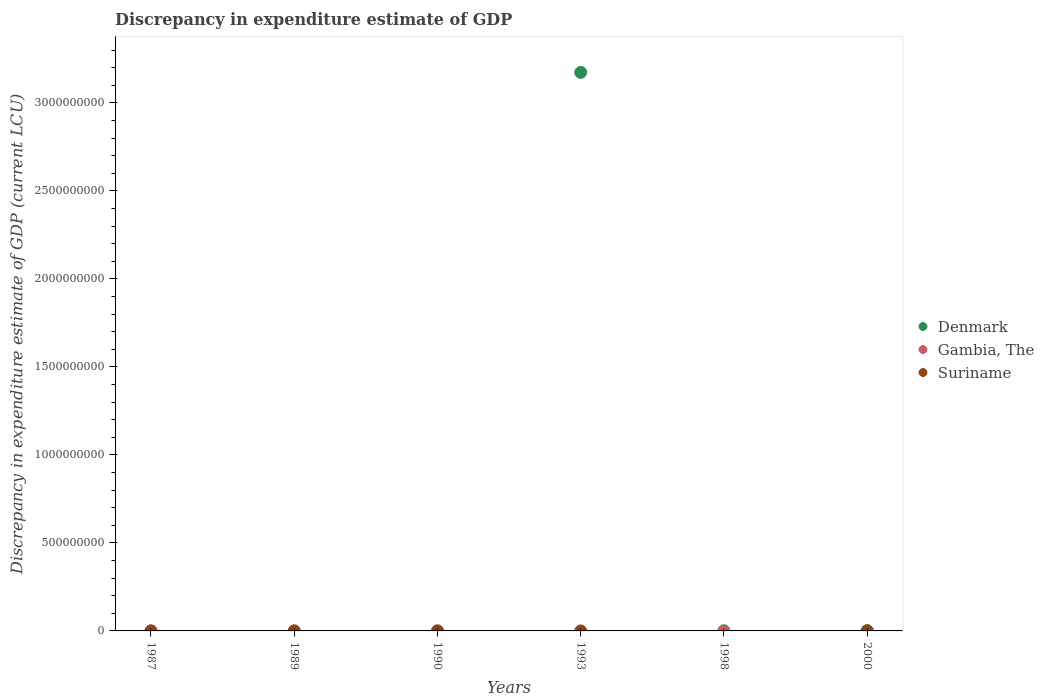Across all years, what is the maximum discrepancy in expenditure estimate of GDP in Denmark?
Your answer should be compact. 3.17e+09. In which year was the discrepancy in expenditure estimate of GDP in Suriname maximum?
Give a very brief answer. 2000. What is the total discrepancy in expenditure estimate of GDP in Denmark in the graph?
Make the answer very short. 3.18e+09. What is the difference between the discrepancy in expenditure estimate of GDP in Suriname in 1993 and the discrepancy in expenditure estimate of GDP in Gambia, The in 2000?
Your answer should be very brief. 0. What is the average discrepancy in expenditure estimate of GDP in Suriname per year?
Keep it short and to the point. 1.25e+05. In the year 2000, what is the difference between the discrepancy in expenditure estimate of GDP in Denmark and discrepancy in expenditure estimate of GDP in Suriname?
Offer a very short reply. 2.52e+05. Is the discrepancy in expenditure estimate of GDP in Suriname in 1989 less than that in 2000?
Your answer should be compact. Yes. What is the difference between the highest and the second highest discrepancy in expenditure estimate of GDP in Denmark?
Keep it short and to the point. 3.17e+09. What is the difference between the highest and the lowest discrepancy in expenditure estimate of GDP in Suriname?
Offer a terse response. 7.48e+05. Is it the case that in every year, the sum of the discrepancy in expenditure estimate of GDP in Gambia, The and discrepancy in expenditure estimate of GDP in Suriname  is greater than the discrepancy in expenditure estimate of GDP in Denmark?
Offer a terse response. No. How many dotlines are there?
Provide a succinct answer. 3. How many years are there in the graph?
Offer a terse response. 6. Does the graph contain grids?
Give a very brief answer. No. What is the title of the graph?
Your response must be concise. Discrepancy in expenditure estimate of GDP. What is the label or title of the Y-axis?
Ensure brevity in your answer.  Discrepancy in expenditure estimate of GDP (current LCU). What is the Discrepancy in expenditure estimate of GDP (current LCU) of Gambia, The in 1987?
Provide a short and direct response. 100. What is the Discrepancy in expenditure estimate of GDP (current LCU) in Denmark in 1989?
Provide a short and direct response. 0. What is the Discrepancy in expenditure estimate of GDP (current LCU) in Gambia, The in 1989?
Offer a terse response. 0. What is the Discrepancy in expenditure estimate of GDP (current LCU) of Suriname in 1989?
Make the answer very short. 100. What is the Discrepancy in expenditure estimate of GDP (current LCU) of Suriname in 1990?
Your answer should be very brief. 0. What is the Discrepancy in expenditure estimate of GDP (current LCU) of Denmark in 1993?
Offer a very short reply. 3.17e+09. What is the Discrepancy in expenditure estimate of GDP (current LCU) of Suriname in 1993?
Your answer should be very brief. 0. What is the Discrepancy in expenditure estimate of GDP (current LCU) of Denmark in 2000?
Keep it short and to the point. 1.00e+06. What is the Discrepancy in expenditure estimate of GDP (current LCU) of Gambia, The in 2000?
Give a very brief answer. 0. What is the Discrepancy in expenditure estimate of GDP (current LCU) in Suriname in 2000?
Provide a succinct answer. 7.48e+05. Across all years, what is the maximum Discrepancy in expenditure estimate of GDP (current LCU) of Denmark?
Make the answer very short. 3.17e+09. Across all years, what is the maximum Discrepancy in expenditure estimate of GDP (current LCU) in Gambia, The?
Your response must be concise. 100. Across all years, what is the maximum Discrepancy in expenditure estimate of GDP (current LCU) in Suriname?
Ensure brevity in your answer.  7.48e+05. What is the total Discrepancy in expenditure estimate of GDP (current LCU) in Denmark in the graph?
Keep it short and to the point. 3.18e+09. What is the total Discrepancy in expenditure estimate of GDP (current LCU) in Gambia, The in the graph?
Provide a succinct answer. 100. What is the total Discrepancy in expenditure estimate of GDP (current LCU) in Suriname in the graph?
Provide a short and direct response. 7.48e+05. What is the difference between the Discrepancy in expenditure estimate of GDP (current LCU) in Suriname in 1989 and that in 2000?
Provide a succinct answer. -7.48e+05. What is the difference between the Discrepancy in expenditure estimate of GDP (current LCU) in Denmark in 1993 and that in 1998?
Provide a short and direct response. 3.17e+09. What is the difference between the Discrepancy in expenditure estimate of GDP (current LCU) of Denmark in 1993 and that in 2000?
Your answer should be compact. 3.17e+09. What is the difference between the Discrepancy in expenditure estimate of GDP (current LCU) of Gambia, The in 1987 and the Discrepancy in expenditure estimate of GDP (current LCU) of Suriname in 2000?
Offer a terse response. -7.48e+05. What is the difference between the Discrepancy in expenditure estimate of GDP (current LCU) of Denmark in 1993 and the Discrepancy in expenditure estimate of GDP (current LCU) of Suriname in 2000?
Provide a short and direct response. 3.17e+09. What is the difference between the Discrepancy in expenditure estimate of GDP (current LCU) in Denmark in 1998 and the Discrepancy in expenditure estimate of GDP (current LCU) in Suriname in 2000?
Keep it short and to the point. 2.52e+05. What is the average Discrepancy in expenditure estimate of GDP (current LCU) in Denmark per year?
Your answer should be compact. 5.29e+08. What is the average Discrepancy in expenditure estimate of GDP (current LCU) of Gambia, The per year?
Make the answer very short. 16.67. What is the average Discrepancy in expenditure estimate of GDP (current LCU) of Suriname per year?
Give a very brief answer. 1.25e+05. In the year 2000, what is the difference between the Discrepancy in expenditure estimate of GDP (current LCU) in Denmark and Discrepancy in expenditure estimate of GDP (current LCU) in Suriname?
Keep it short and to the point. 2.52e+05. What is the ratio of the Discrepancy in expenditure estimate of GDP (current LCU) in Denmark in 1993 to that in 1998?
Ensure brevity in your answer.  3173.57. What is the ratio of the Discrepancy in expenditure estimate of GDP (current LCU) in Denmark in 1993 to that in 2000?
Make the answer very short. 3173.57. What is the ratio of the Discrepancy in expenditure estimate of GDP (current LCU) in Denmark in 1998 to that in 2000?
Keep it short and to the point. 1. What is the difference between the highest and the second highest Discrepancy in expenditure estimate of GDP (current LCU) of Denmark?
Your answer should be compact. 3.17e+09. What is the difference between the highest and the lowest Discrepancy in expenditure estimate of GDP (current LCU) in Denmark?
Your answer should be very brief. 3.17e+09. What is the difference between the highest and the lowest Discrepancy in expenditure estimate of GDP (current LCU) of Gambia, The?
Offer a very short reply. 100. What is the difference between the highest and the lowest Discrepancy in expenditure estimate of GDP (current LCU) of Suriname?
Offer a very short reply. 7.48e+05. 